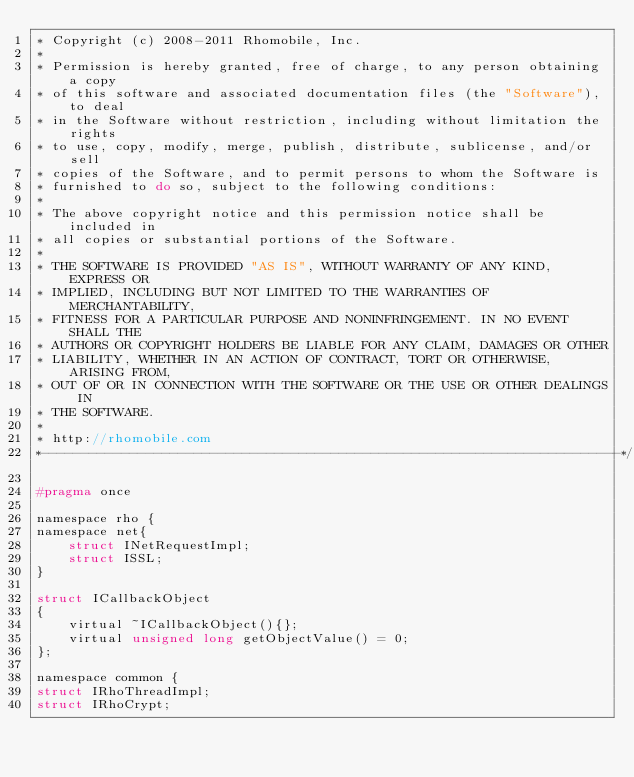Convert code to text. <code><loc_0><loc_0><loc_500><loc_500><_C_>* Copyright (c) 2008-2011 Rhomobile, Inc.
*
* Permission is hereby granted, free of charge, to any person obtaining a copy
* of this software and associated documentation files (the "Software"), to deal
* in the Software without restriction, including without limitation the rights
* to use, copy, modify, merge, publish, distribute, sublicense, and/or sell
* copies of the Software, and to permit persons to whom the Software is
* furnished to do so, subject to the following conditions:
*
* The above copyright notice and this permission notice shall be included in
* all copies or substantial portions of the Software.
*
* THE SOFTWARE IS PROVIDED "AS IS", WITHOUT WARRANTY OF ANY KIND, EXPRESS OR
* IMPLIED, INCLUDING BUT NOT LIMITED TO THE WARRANTIES OF MERCHANTABILITY,
* FITNESS FOR A PARTICULAR PURPOSE AND NONINFRINGEMENT. IN NO EVENT SHALL THE
* AUTHORS OR COPYRIGHT HOLDERS BE LIABLE FOR ANY CLAIM, DAMAGES OR OTHER
* LIABILITY, WHETHER IN AN ACTION OF CONTRACT, TORT OR OTHERWISE, ARISING FROM,
* OUT OF OR IN CONNECTION WITH THE SOFTWARE OR THE USE OR OTHER DEALINGS IN
* THE SOFTWARE.
*
* http://rhomobile.com
*------------------------------------------------------------------------*/

#pragma once

namespace rho {
namespace net{
    struct INetRequestImpl;
    struct ISSL;
}

struct ICallbackObject
{
    virtual ~ICallbackObject(){};
    virtual unsigned long getObjectValue() = 0;
};

namespace common {
struct IRhoThreadImpl;
struct IRhoCrypt;</code> 